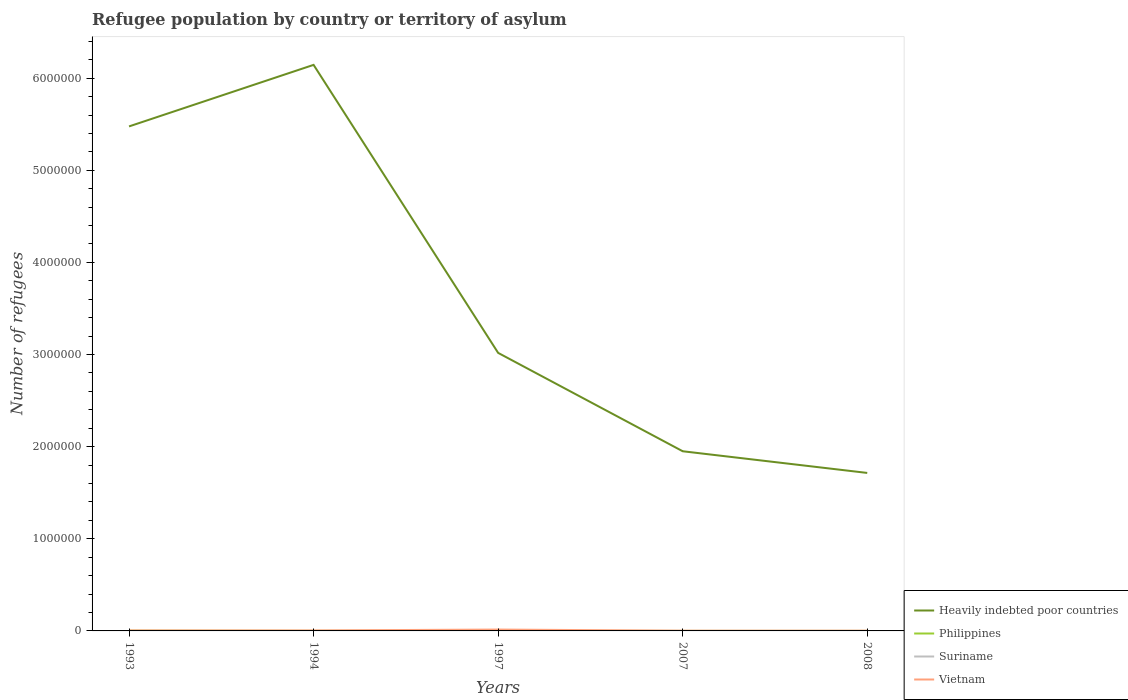Does the line corresponding to Vietnam intersect with the line corresponding to Heavily indebted poor countries?
Provide a short and direct response. No. Is the number of lines equal to the number of legend labels?
Ensure brevity in your answer.  Yes. What is the total number of refugees in Heavily indebted poor countries in the graph?
Give a very brief answer. 4.19e+06. What is the difference between the highest and the second highest number of refugees in Philippines?
Your answer should be very brief. 2373. What is the difference between the highest and the lowest number of refugees in Heavily indebted poor countries?
Provide a succinct answer. 2. Is the number of refugees in Suriname strictly greater than the number of refugees in Vietnam over the years?
Keep it short and to the point. Yes. Are the values on the major ticks of Y-axis written in scientific E-notation?
Your answer should be compact. No. Does the graph contain grids?
Your answer should be very brief. No. Where does the legend appear in the graph?
Your answer should be compact. Bottom right. How are the legend labels stacked?
Your answer should be compact. Vertical. What is the title of the graph?
Ensure brevity in your answer.  Refugee population by country or territory of asylum. What is the label or title of the X-axis?
Give a very brief answer. Years. What is the label or title of the Y-axis?
Provide a succinct answer. Number of refugees. What is the Number of refugees in Heavily indebted poor countries in 1993?
Offer a terse response. 5.48e+06. What is the Number of refugees of Philippines in 1993?
Provide a succinct answer. 2477. What is the Number of refugees of Suriname in 1993?
Keep it short and to the point. 50. What is the Number of refugees of Vietnam in 1993?
Keep it short and to the point. 5084. What is the Number of refugees in Heavily indebted poor countries in 1994?
Give a very brief answer. 6.14e+06. What is the Number of refugees in Philippines in 1994?
Your answer should be very brief. 669. What is the Number of refugees in Suriname in 1994?
Ensure brevity in your answer.  39. What is the Number of refugees in Vietnam in 1994?
Make the answer very short. 5000. What is the Number of refugees in Heavily indebted poor countries in 1997?
Offer a terse response. 3.02e+06. What is the Number of refugees of Philippines in 1997?
Offer a very short reply. 311. What is the Number of refugees of Suriname in 1997?
Offer a terse response. 11. What is the Number of refugees in Vietnam in 1997?
Your answer should be very brief. 1.50e+04. What is the Number of refugees of Heavily indebted poor countries in 2007?
Your answer should be compact. 1.95e+06. What is the Number of refugees of Philippines in 2007?
Ensure brevity in your answer.  106. What is the Number of refugees in Vietnam in 2007?
Give a very brief answer. 2357. What is the Number of refugees of Heavily indebted poor countries in 2008?
Keep it short and to the point. 1.71e+06. What is the Number of refugees in Philippines in 2008?
Keep it short and to the point. 104. What is the Number of refugees of Vietnam in 2008?
Offer a very short reply. 2357. Across all years, what is the maximum Number of refugees of Heavily indebted poor countries?
Keep it short and to the point. 6.14e+06. Across all years, what is the maximum Number of refugees of Philippines?
Provide a short and direct response. 2477. Across all years, what is the maximum Number of refugees in Vietnam?
Give a very brief answer. 1.50e+04. Across all years, what is the minimum Number of refugees in Heavily indebted poor countries?
Offer a very short reply. 1.71e+06. Across all years, what is the minimum Number of refugees of Philippines?
Offer a terse response. 104. Across all years, what is the minimum Number of refugees in Suriname?
Offer a very short reply. 1. Across all years, what is the minimum Number of refugees in Vietnam?
Keep it short and to the point. 2357. What is the total Number of refugees of Heavily indebted poor countries in the graph?
Offer a terse response. 1.83e+07. What is the total Number of refugees of Philippines in the graph?
Keep it short and to the point. 3667. What is the total Number of refugees of Suriname in the graph?
Offer a very short reply. 102. What is the total Number of refugees of Vietnam in the graph?
Provide a succinct answer. 2.98e+04. What is the difference between the Number of refugees in Heavily indebted poor countries in 1993 and that in 1994?
Make the answer very short. -6.68e+05. What is the difference between the Number of refugees in Philippines in 1993 and that in 1994?
Your answer should be very brief. 1808. What is the difference between the Number of refugees in Suriname in 1993 and that in 1994?
Provide a succinct answer. 11. What is the difference between the Number of refugees of Heavily indebted poor countries in 1993 and that in 1997?
Provide a succinct answer. 2.46e+06. What is the difference between the Number of refugees of Philippines in 1993 and that in 1997?
Offer a very short reply. 2166. What is the difference between the Number of refugees of Suriname in 1993 and that in 1997?
Your answer should be very brief. 39. What is the difference between the Number of refugees in Vietnam in 1993 and that in 1997?
Your answer should be compact. -9916. What is the difference between the Number of refugees in Heavily indebted poor countries in 1993 and that in 2007?
Provide a short and direct response. 3.53e+06. What is the difference between the Number of refugees in Philippines in 1993 and that in 2007?
Provide a succinct answer. 2371. What is the difference between the Number of refugees in Vietnam in 1993 and that in 2007?
Offer a terse response. 2727. What is the difference between the Number of refugees of Heavily indebted poor countries in 1993 and that in 2008?
Offer a terse response. 3.76e+06. What is the difference between the Number of refugees in Philippines in 1993 and that in 2008?
Your response must be concise. 2373. What is the difference between the Number of refugees in Suriname in 1993 and that in 2008?
Make the answer very short. 49. What is the difference between the Number of refugees in Vietnam in 1993 and that in 2008?
Your answer should be very brief. 2727. What is the difference between the Number of refugees in Heavily indebted poor countries in 1994 and that in 1997?
Provide a short and direct response. 3.13e+06. What is the difference between the Number of refugees in Philippines in 1994 and that in 1997?
Your answer should be very brief. 358. What is the difference between the Number of refugees of Heavily indebted poor countries in 1994 and that in 2007?
Your answer should be very brief. 4.19e+06. What is the difference between the Number of refugees of Philippines in 1994 and that in 2007?
Give a very brief answer. 563. What is the difference between the Number of refugees in Vietnam in 1994 and that in 2007?
Keep it short and to the point. 2643. What is the difference between the Number of refugees of Heavily indebted poor countries in 1994 and that in 2008?
Your answer should be compact. 4.43e+06. What is the difference between the Number of refugees of Philippines in 1994 and that in 2008?
Make the answer very short. 565. What is the difference between the Number of refugees of Suriname in 1994 and that in 2008?
Offer a very short reply. 38. What is the difference between the Number of refugees in Vietnam in 1994 and that in 2008?
Make the answer very short. 2643. What is the difference between the Number of refugees of Heavily indebted poor countries in 1997 and that in 2007?
Provide a short and direct response. 1.07e+06. What is the difference between the Number of refugees in Philippines in 1997 and that in 2007?
Your response must be concise. 205. What is the difference between the Number of refugees in Suriname in 1997 and that in 2007?
Your answer should be compact. 10. What is the difference between the Number of refugees in Vietnam in 1997 and that in 2007?
Give a very brief answer. 1.26e+04. What is the difference between the Number of refugees of Heavily indebted poor countries in 1997 and that in 2008?
Your response must be concise. 1.30e+06. What is the difference between the Number of refugees in Philippines in 1997 and that in 2008?
Make the answer very short. 207. What is the difference between the Number of refugees of Suriname in 1997 and that in 2008?
Your answer should be very brief. 10. What is the difference between the Number of refugees of Vietnam in 1997 and that in 2008?
Provide a succinct answer. 1.26e+04. What is the difference between the Number of refugees of Heavily indebted poor countries in 2007 and that in 2008?
Ensure brevity in your answer.  2.35e+05. What is the difference between the Number of refugees in Philippines in 2007 and that in 2008?
Your answer should be very brief. 2. What is the difference between the Number of refugees in Heavily indebted poor countries in 1993 and the Number of refugees in Philippines in 1994?
Ensure brevity in your answer.  5.48e+06. What is the difference between the Number of refugees in Heavily indebted poor countries in 1993 and the Number of refugees in Suriname in 1994?
Make the answer very short. 5.48e+06. What is the difference between the Number of refugees in Heavily indebted poor countries in 1993 and the Number of refugees in Vietnam in 1994?
Provide a succinct answer. 5.47e+06. What is the difference between the Number of refugees of Philippines in 1993 and the Number of refugees of Suriname in 1994?
Ensure brevity in your answer.  2438. What is the difference between the Number of refugees of Philippines in 1993 and the Number of refugees of Vietnam in 1994?
Offer a terse response. -2523. What is the difference between the Number of refugees of Suriname in 1993 and the Number of refugees of Vietnam in 1994?
Your answer should be very brief. -4950. What is the difference between the Number of refugees of Heavily indebted poor countries in 1993 and the Number of refugees of Philippines in 1997?
Provide a short and direct response. 5.48e+06. What is the difference between the Number of refugees of Heavily indebted poor countries in 1993 and the Number of refugees of Suriname in 1997?
Make the answer very short. 5.48e+06. What is the difference between the Number of refugees of Heavily indebted poor countries in 1993 and the Number of refugees of Vietnam in 1997?
Keep it short and to the point. 5.46e+06. What is the difference between the Number of refugees of Philippines in 1993 and the Number of refugees of Suriname in 1997?
Your answer should be very brief. 2466. What is the difference between the Number of refugees of Philippines in 1993 and the Number of refugees of Vietnam in 1997?
Your response must be concise. -1.25e+04. What is the difference between the Number of refugees in Suriname in 1993 and the Number of refugees in Vietnam in 1997?
Your response must be concise. -1.50e+04. What is the difference between the Number of refugees in Heavily indebted poor countries in 1993 and the Number of refugees in Philippines in 2007?
Your answer should be compact. 5.48e+06. What is the difference between the Number of refugees of Heavily indebted poor countries in 1993 and the Number of refugees of Suriname in 2007?
Offer a terse response. 5.48e+06. What is the difference between the Number of refugees of Heavily indebted poor countries in 1993 and the Number of refugees of Vietnam in 2007?
Your answer should be very brief. 5.47e+06. What is the difference between the Number of refugees of Philippines in 1993 and the Number of refugees of Suriname in 2007?
Your response must be concise. 2476. What is the difference between the Number of refugees in Philippines in 1993 and the Number of refugees in Vietnam in 2007?
Provide a short and direct response. 120. What is the difference between the Number of refugees in Suriname in 1993 and the Number of refugees in Vietnam in 2007?
Your response must be concise. -2307. What is the difference between the Number of refugees of Heavily indebted poor countries in 1993 and the Number of refugees of Philippines in 2008?
Your answer should be very brief. 5.48e+06. What is the difference between the Number of refugees of Heavily indebted poor countries in 1993 and the Number of refugees of Suriname in 2008?
Ensure brevity in your answer.  5.48e+06. What is the difference between the Number of refugees in Heavily indebted poor countries in 1993 and the Number of refugees in Vietnam in 2008?
Your response must be concise. 5.47e+06. What is the difference between the Number of refugees in Philippines in 1993 and the Number of refugees in Suriname in 2008?
Provide a succinct answer. 2476. What is the difference between the Number of refugees in Philippines in 1993 and the Number of refugees in Vietnam in 2008?
Offer a very short reply. 120. What is the difference between the Number of refugees of Suriname in 1993 and the Number of refugees of Vietnam in 2008?
Give a very brief answer. -2307. What is the difference between the Number of refugees in Heavily indebted poor countries in 1994 and the Number of refugees in Philippines in 1997?
Keep it short and to the point. 6.14e+06. What is the difference between the Number of refugees of Heavily indebted poor countries in 1994 and the Number of refugees of Suriname in 1997?
Your answer should be compact. 6.14e+06. What is the difference between the Number of refugees of Heavily indebted poor countries in 1994 and the Number of refugees of Vietnam in 1997?
Your response must be concise. 6.13e+06. What is the difference between the Number of refugees of Philippines in 1994 and the Number of refugees of Suriname in 1997?
Your answer should be very brief. 658. What is the difference between the Number of refugees in Philippines in 1994 and the Number of refugees in Vietnam in 1997?
Ensure brevity in your answer.  -1.43e+04. What is the difference between the Number of refugees in Suriname in 1994 and the Number of refugees in Vietnam in 1997?
Make the answer very short. -1.50e+04. What is the difference between the Number of refugees in Heavily indebted poor countries in 1994 and the Number of refugees in Philippines in 2007?
Provide a short and direct response. 6.14e+06. What is the difference between the Number of refugees of Heavily indebted poor countries in 1994 and the Number of refugees of Suriname in 2007?
Make the answer very short. 6.14e+06. What is the difference between the Number of refugees in Heavily indebted poor countries in 1994 and the Number of refugees in Vietnam in 2007?
Give a very brief answer. 6.14e+06. What is the difference between the Number of refugees of Philippines in 1994 and the Number of refugees of Suriname in 2007?
Provide a short and direct response. 668. What is the difference between the Number of refugees of Philippines in 1994 and the Number of refugees of Vietnam in 2007?
Your answer should be compact. -1688. What is the difference between the Number of refugees of Suriname in 1994 and the Number of refugees of Vietnam in 2007?
Your response must be concise. -2318. What is the difference between the Number of refugees of Heavily indebted poor countries in 1994 and the Number of refugees of Philippines in 2008?
Provide a short and direct response. 6.14e+06. What is the difference between the Number of refugees in Heavily indebted poor countries in 1994 and the Number of refugees in Suriname in 2008?
Your answer should be very brief. 6.14e+06. What is the difference between the Number of refugees of Heavily indebted poor countries in 1994 and the Number of refugees of Vietnam in 2008?
Ensure brevity in your answer.  6.14e+06. What is the difference between the Number of refugees of Philippines in 1994 and the Number of refugees of Suriname in 2008?
Make the answer very short. 668. What is the difference between the Number of refugees in Philippines in 1994 and the Number of refugees in Vietnam in 2008?
Give a very brief answer. -1688. What is the difference between the Number of refugees in Suriname in 1994 and the Number of refugees in Vietnam in 2008?
Your answer should be compact. -2318. What is the difference between the Number of refugees in Heavily indebted poor countries in 1997 and the Number of refugees in Philippines in 2007?
Provide a short and direct response. 3.02e+06. What is the difference between the Number of refugees of Heavily indebted poor countries in 1997 and the Number of refugees of Suriname in 2007?
Offer a very short reply. 3.02e+06. What is the difference between the Number of refugees in Heavily indebted poor countries in 1997 and the Number of refugees in Vietnam in 2007?
Offer a terse response. 3.02e+06. What is the difference between the Number of refugees in Philippines in 1997 and the Number of refugees in Suriname in 2007?
Your answer should be compact. 310. What is the difference between the Number of refugees of Philippines in 1997 and the Number of refugees of Vietnam in 2007?
Your answer should be compact. -2046. What is the difference between the Number of refugees in Suriname in 1997 and the Number of refugees in Vietnam in 2007?
Your answer should be compact. -2346. What is the difference between the Number of refugees of Heavily indebted poor countries in 1997 and the Number of refugees of Philippines in 2008?
Give a very brief answer. 3.02e+06. What is the difference between the Number of refugees in Heavily indebted poor countries in 1997 and the Number of refugees in Suriname in 2008?
Offer a very short reply. 3.02e+06. What is the difference between the Number of refugees of Heavily indebted poor countries in 1997 and the Number of refugees of Vietnam in 2008?
Your answer should be very brief. 3.02e+06. What is the difference between the Number of refugees in Philippines in 1997 and the Number of refugees in Suriname in 2008?
Your response must be concise. 310. What is the difference between the Number of refugees of Philippines in 1997 and the Number of refugees of Vietnam in 2008?
Ensure brevity in your answer.  -2046. What is the difference between the Number of refugees of Suriname in 1997 and the Number of refugees of Vietnam in 2008?
Keep it short and to the point. -2346. What is the difference between the Number of refugees in Heavily indebted poor countries in 2007 and the Number of refugees in Philippines in 2008?
Your response must be concise. 1.95e+06. What is the difference between the Number of refugees in Heavily indebted poor countries in 2007 and the Number of refugees in Suriname in 2008?
Your answer should be compact. 1.95e+06. What is the difference between the Number of refugees of Heavily indebted poor countries in 2007 and the Number of refugees of Vietnam in 2008?
Your answer should be compact. 1.95e+06. What is the difference between the Number of refugees in Philippines in 2007 and the Number of refugees in Suriname in 2008?
Your answer should be very brief. 105. What is the difference between the Number of refugees of Philippines in 2007 and the Number of refugees of Vietnam in 2008?
Provide a short and direct response. -2251. What is the difference between the Number of refugees in Suriname in 2007 and the Number of refugees in Vietnam in 2008?
Your answer should be very brief. -2356. What is the average Number of refugees of Heavily indebted poor countries per year?
Keep it short and to the point. 3.66e+06. What is the average Number of refugees in Philippines per year?
Offer a very short reply. 733.4. What is the average Number of refugees of Suriname per year?
Your answer should be compact. 20.4. What is the average Number of refugees of Vietnam per year?
Offer a very short reply. 5959.6. In the year 1993, what is the difference between the Number of refugees of Heavily indebted poor countries and Number of refugees of Philippines?
Provide a succinct answer. 5.47e+06. In the year 1993, what is the difference between the Number of refugees in Heavily indebted poor countries and Number of refugees in Suriname?
Make the answer very short. 5.48e+06. In the year 1993, what is the difference between the Number of refugees of Heavily indebted poor countries and Number of refugees of Vietnam?
Offer a very short reply. 5.47e+06. In the year 1993, what is the difference between the Number of refugees in Philippines and Number of refugees in Suriname?
Make the answer very short. 2427. In the year 1993, what is the difference between the Number of refugees of Philippines and Number of refugees of Vietnam?
Your answer should be compact. -2607. In the year 1993, what is the difference between the Number of refugees in Suriname and Number of refugees in Vietnam?
Keep it short and to the point. -5034. In the year 1994, what is the difference between the Number of refugees of Heavily indebted poor countries and Number of refugees of Philippines?
Offer a terse response. 6.14e+06. In the year 1994, what is the difference between the Number of refugees of Heavily indebted poor countries and Number of refugees of Suriname?
Ensure brevity in your answer.  6.14e+06. In the year 1994, what is the difference between the Number of refugees of Heavily indebted poor countries and Number of refugees of Vietnam?
Your response must be concise. 6.14e+06. In the year 1994, what is the difference between the Number of refugees of Philippines and Number of refugees of Suriname?
Keep it short and to the point. 630. In the year 1994, what is the difference between the Number of refugees in Philippines and Number of refugees in Vietnam?
Give a very brief answer. -4331. In the year 1994, what is the difference between the Number of refugees in Suriname and Number of refugees in Vietnam?
Give a very brief answer. -4961. In the year 1997, what is the difference between the Number of refugees in Heavily indebted poor countries and Number of refugees in Philippines?
Your response must be concise. 3.02e+06. In the year 1997, what is the difference between the Number of refugees in Heavily indebted poor countries and Number of refugees in Suriname?
Offer a terse response. 3.02e+06. In the year 1997, what is the difference between the Number of refugees in Heavily indebted poor countries and Number of refugees in Vietnam?
Your answer should be very brief. 3.00e+06. In the year 1997, what is the difference between the Number of refugees of Philippines and Number of refugees of Suriname?
Make the answer very short. 300. In the year 1997, what is the difference between the Number of refugees of Philippines and Number of refugees of Vietnam?
Your answer should be compact. -1.47e+04. In the year 1997, what is the difference between the Number of refugees of Suriname and Number of refugees of Vietnam?
Your answer should be very brief. -1.50e+04. In the year 2007, what is the difference between the Number of refugees in Heavily indebted poor countries and Number of refugees in Philippines?
Give a very brief answer. 1.95e+06. In the year 2007, what is the difference between the Number of refugees in Heavily indebted poor countries and Number of refugees in Suriname?
Your response must be concise. 1.95e+06. In the year 2007, what is the difference between the Number of refugees in Heavily indebted poor countries and Number of refugees in Vietnam?
Your answer should be compact. 1.95e+06. In the year 2007, what is the difference between the Number of refugees of Philippines and Number of refugees of Suriname?
Offer a terse response. 105. In the year 2007, what is the difference between the Number of refugees in Philippines and Number of refugees in Vietnam?
Offer a very short reply. -2251. In the year 2007, what is the difference between the Number of refugees in Suriname and Number of refugees in Vietnam?
Keep it short and to the point. -2356. In the year 2008, what is the difference between the Number of refugees of Heavily indebted poor countries and Number of refugees of Philippines?
Provide a succinct answer. 1.71e+06. In the year 2008, what is the difference between the Number of refugees in Heavily indebted poor countries and Number of refugees in Suriname?
Keep it short and to the point. 1.71e+06. In the year 2008, what is the difference between the Number of refugees of Heavily indebted poor countries and Number of refugees of Vietnam?
Provide a succinct answer. 1.71e+06. In the year 2008, what is the difference between the Number of refugees of Philippines and Number of refugees of Suriname?
Offer a very short reply. 103. In the year 2008, what is the difference between the Number of refugees in Philippines and Number of refugees in Vietnam?
Your answer should be very brief. -2253. In the year 2008, what is the difference between the Number of refugees of Suriname and Number of refugees of Vietnam?
Keep it short and to the point. -2356. What is the ratio of the Number of refugees of Heavily indebted poor countries in 1993 to that in 1994?
Offer a terse response. 0.89. What is the ratio of the Number of refugees of Philippines in 1993 to that in 1994?
Provide a short and direct response. 3.7. What is the ratio of the Number of refugees of Suriname in 1993 to that in 1994?
Give a very brief answer. 1.28. What is the ratio of the Number of refugees of Vietnam in 1993 to that in 1994?
Provide a short and direct response. 1.02. What is the ratio of the Number of refugees of Heavily indebted poor countries in 1993 to that in 1997?
Your answer should be very brief. 1.81. What is the ratio of the Number of refugees of Philippines in 1993 to that in 1997?
Your answer should be very brief. 7.96. What is the ratio of the Number of refugees in Suriname in 1993 to that in 1997?
Ensure brevity in your answer.  4.55. What is the ratio of the Number of refugees of Vietnam in 1993 to that in 1997?
Provide a succinct answer. 0.34. What is the ratio of the Number of refugees of Heavily indebted poor countries in 1993 to that in 2007?
Offer a terse response. 2.81. What is the ratio of the Number of refugees in Philippines in 1993 to that in 2007?
Offer a very short reply. 23.37. What is the ratio of the Number of refugees of Suriname in 1993 to that in 2007?
Your response must be concise. 50. What is the ratio of the Number of refugees of Vietnam in 1993 to that in 2007?
Offer a very short reply. 2.16. What is the ratio of the Number of refugees in Heavily indebted poor countries in 1993 to that in 2008?
Keep it short and to the point. 3.19. What is the ratio of the Number of refugees of Philippines in 1993 to that in 2008?
Your response must be concise. 23.82. What is the ratio of the Number of refugees of Vietnam in 1993 to that in 2008?
Offer a terse response. 2.16. What is the ratio of the Number of refugees of Heavily indebted poor countries in 1994 to that in 1997?
Your answer should be compact. 2.04. What is the ratio of the Number of refugees of Philippines in 1994 to that in 1997?
Provide a succinct answer. 2.15. What is the ratio of the Number of refugees of Suriname in 1994 to that in 1997?
Your answer should be very brief. 3.55. What is the ratio of the Number of refugees in Heavily indebted poor countries in 1994 to that in 2007?
Your answer should be compact. 3.15. What is the ratio of the Number of refugees of Philippines in 1994 to that in 2007?
Give a very brief answer. 6.31. What is the ratio of the Number of refugees of Vietnam in 1994 to that in 2007?
Provide a short and direct response. 2.12. What is the ratio of the Number of refugees in Heavily indebted poor countries in 1994 to that in 2008?
Give a very brief answer. 3.58. What is the ratio of the Number of refugees of Philippines in 1994 to that in 2008?
Give a very brief answer. 6.43. What is the ratio of the Number of refugees of Suriname in 1994 to that in 2008?
Your answer should be very brief. 39. What is the ratio of the Number of refugees in Vietnam in 1994 to that in 2008?
Give a very brief answer. 2.12. What is the ratio of the Number of refugees of Heavily indebted poor countries in 1997 to that in 2007?
Offer a very short reply. 1.55. What is the ratio of the Number of refugees of Philippines in 1997 to that in 2007?
Ensure brevity in your answer.  2.93. What is the ratio of the Number of refugees of Suriname in 1997 to that in 2007?
Provide a succinct answer. 11. What is the ratio of the Number of refugees of Vietnam in 1997 to that in 2007?
Your response must be concise. 6.36. What is the ratio of the Number of refugees in Heavily indebted poor countries in 1997 to that in 2008?
Provide a succinct answer. 1.76. What is the ratio of the Number of refugees of Philippines in 1997 to that in 2008?
Give a very brief answer. 2.99. What is the ratio of the Number of refugees of Suriname in 1997 to that in 2008?
Ensure brevity in your answer.  11. What is the ratio of the Number of refugees in Vietnam in 1997 to that in 2008?
Provide a short and direct response. 6.36. What is the ratio of the Number of refugees in Heavily indebted poor countries in 2007 to that in 2008?
Make the answer very short. 1.14. What is the ratio of the Number of refugees in Philippines in 2007 to that in 2008?
Make the answer very short. 1.02. What is the ratio of the Number of refugees in Suriname in 2007 to that in 2008?
Your answer should be very brief. 1. What is the difference between the highest and the second highest Number of refugees of Heavily indebted poor countries?
Your answer should be very brief. 6.68e+05. What is the difference between the highest and the second highest Number of refugees in Philippines?
Make the answer very short. 1808. What is the difference between the highest and the second highest Number of refugees of Vietnam?
Your answer should be compact. 9916. What is the difference between the highest and the lowest Number of refugees of Heavily indebted poor countries?
Your response must be concise. 4.43e+06. What is the difference between the highest and the lowest Number of refugees of Philippines?
Offer a terse response. 2373. What is the difference between the highest and the lowest Number of refugees in Vietnam?
Make the answer very short. 1.26e+04. 